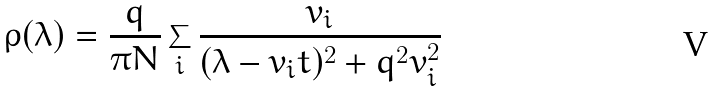<formula> <loc_0><loc_0><loc_500><loc_500>\rho ( \lambda ) = \frac { q } { \pi N } \sum _ { i } \frac { v _ { i } } { ( \lambda - v _ { i } t ) ^ { 2 } + q ^ { 2 } v _ { i } ^ { 2 } }</formula> 